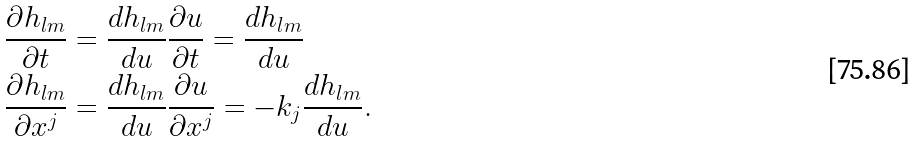Convert formula to latex. <formula><loc_0><loc_0><loc_500><loc_500>\frac { \partial h _ { l m } } { \partial t } & = \frac { d h _ { l m } } { d u } \frac { \partial u } { \partial t } = \frac { d h _ { l m } } { d u } \\ \frac { \partial h _ { l m } } { \partial x ^ { j } } & = \frac { d h _ { l m } } { d u } \frac { \partial u } { \partial x ^ { j } } = - k _ { j } \frac { d h _ { l m } } { d u } .</formula> 